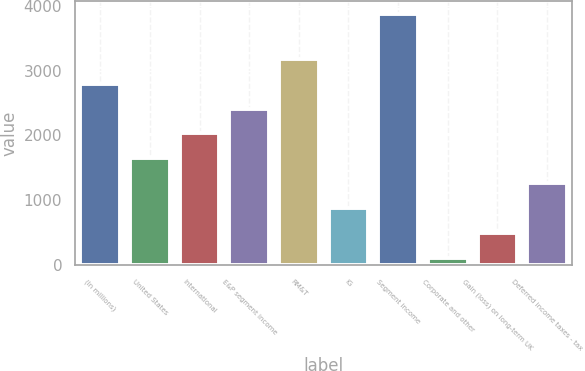Convert chart to OTSL. <chart><loc_0><loc_0><loc_500><loc_500><bar_chart><fcel>(In millions)<fcel>United States<fcel>International<fcel>E&P segment income<fcel>RM&T<fcel>IG<fcel>Segment income<fcel>Corporate and other<fcel>Gain (loss) on long-term UK<fcel>Deferred income taxes - tax<nl><fcel>2800.4<fcel>1644.8<fcel>2030<fcel>2415.2<fcel>3185.6<fcel>874.4<fcel>3875<fcel>104<fcel>489.2<fcel>1259.6<nl></chart> 